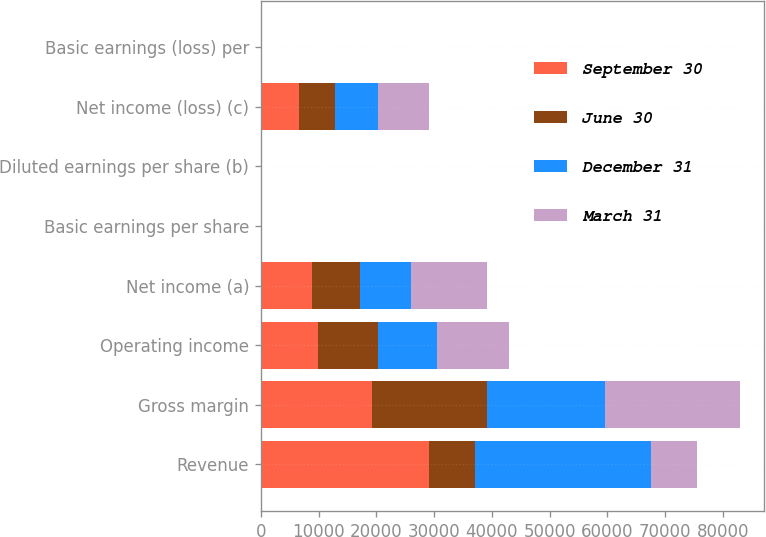Convert chart. <chart><loc_0><loc_0><loc_500><loc_500><stacked_bar_chart><ecel><fcel>Revenue<fcel>Gross margin<fcel>Operating income<fcel>Net income (a)<fcel>Basic earnings per share<fcel>Diluted earnings per share (b)<fcel>Net income (loss) (c)<fcel>Basic earnings (loss) per<nl><fcel>September 30<fcel>29084<fcel>19179<fcel>9955<fcel>8824<fcel>1.15<fcel>1.14<fcel>6576<fcel>0.85<nl><fcel>June 30<fcel>7922<fcel>20048<fcel>10258<fcel>8420<fcel>1.09<fcel>1.08<fcel>6302<fcel>0.82<nl><fcel>December 31<fcel>30571<fcel>20401<fcel>10341<fcel>8809<fcel>1.15<fcel>1.14<fcel>7424<fcel>0.96<nl><fcel>March 31<fcel>7922<fcel>23305<fcel>12405<fcel>13187<fcel>1.72<fcel>1.71<fcel>8873<fcel>1.15<nl></chart> 